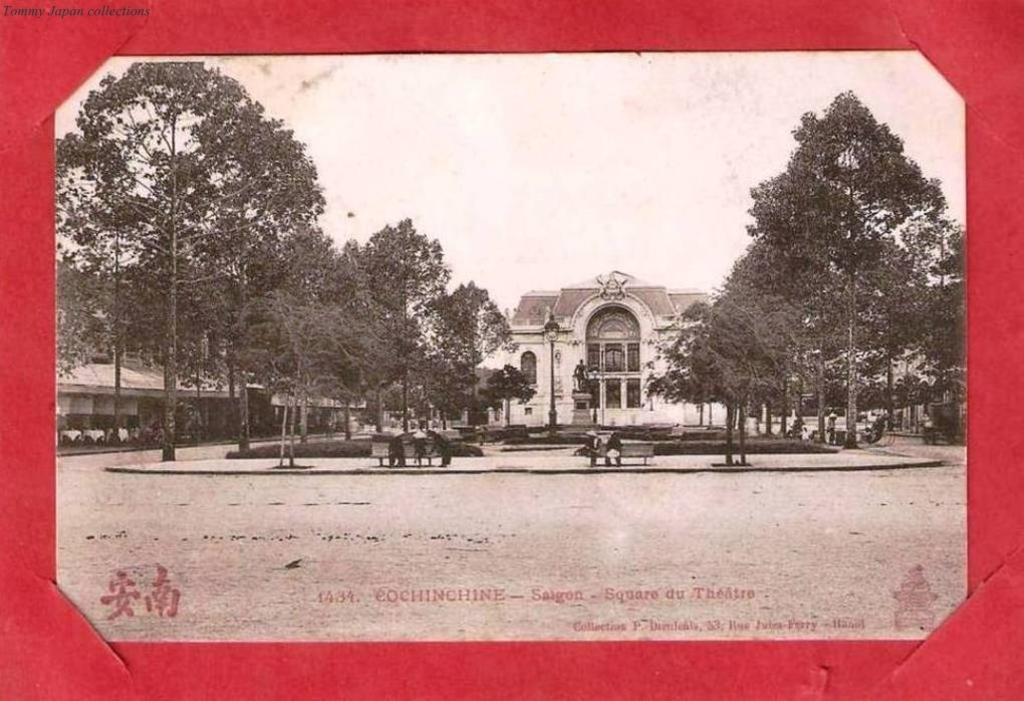What is the main object in the image? There is a frame in the image. What can be seen inside the frame? Trees, benches, plants, a shed, a pole, a sculpture, a building, and people are visible inside the frame. What is the background of the image? The sky is visible in the background of the image. How many rooms can be seen in the image? There is no room present in the image; it features a frame with various outdoor elements. What type of beetle can be seen in the image? There is no beetle present in the image. 